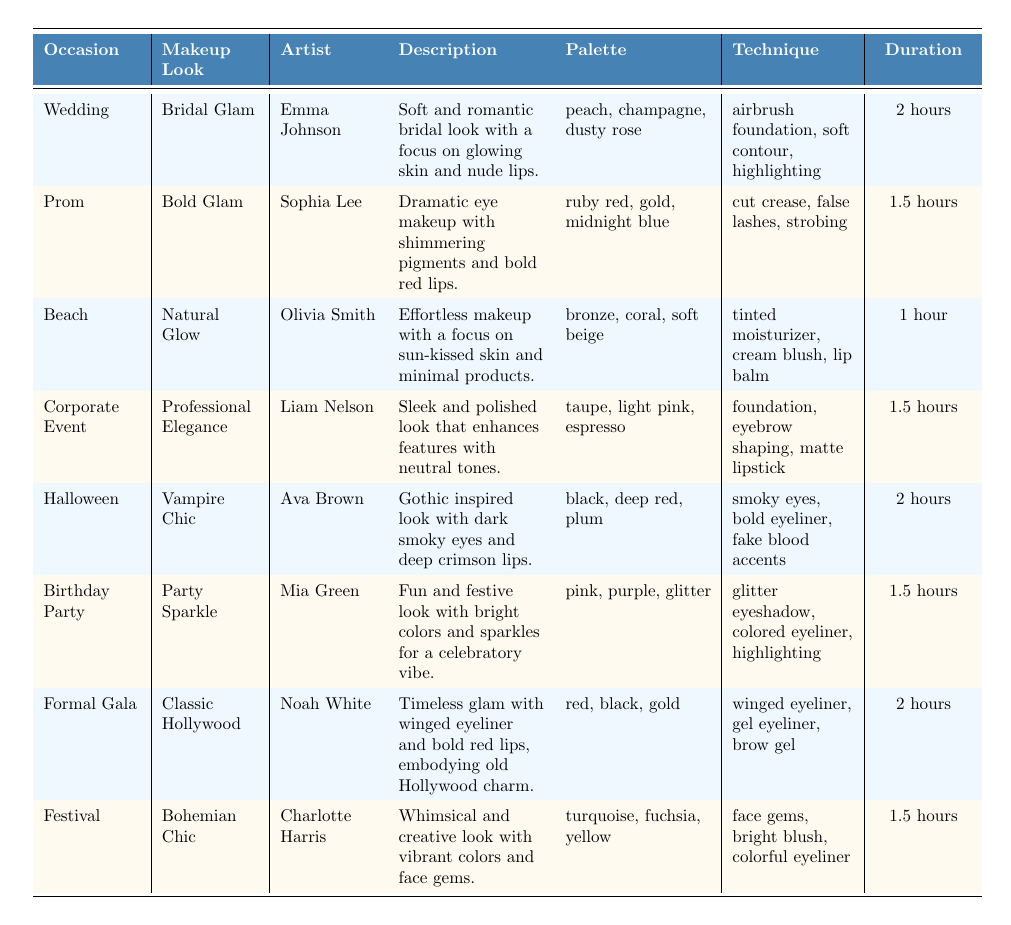What makeup look is associated with the Halloween occasion? The table indicates that the makeup look for Halloween is "Vampire Chic," as listed under the "occasion" column.
Answer: Vampire Chic Who is the artist for the makeup look "Bridal Glam"? According to the table, "Bridal Glam" was created by the artist Emma Johnson, as noted in the corresponding row.
Answer: Emma Johnson What is the duration needed for the "Party Sparkle" makeup look? From the table, the duration for the "Party Sparkle" makeup look is 1.5 hours, as specified in the duration column for that row.
Answer: 1.5 hours Is the "Natural Glow" makeup look designed for a birthday party? The table shows that "Natural Glow" is specifically associated with the Beach occasion, not a birthday party, as reflected in the occasions listed.
Answer: No Which makeup look requires the most time to complete? By analyzing the durations listed, "Bridal Glam," "Vampire Chic," and "Classic Hollywood" all require 2 hours, which is the maximum duration mentioned in the table.
Answer: Bridal Glam, Vampire Chic, Classic Hollywood What palette is used for the "Bohemian Chic" makeup look? The table lists "Bohemian Chic" under festival, and its palette includes turquoise, fuchsia, and yellow, as indicated in the corresponding row.
Answer: Turquoise, fuchsia, yellow What is the average duration of makeup looks listed for events with a duration of 1.5 hours? There are three makeup looks (Bold Glam, Professional Elegance, Party Sparkle) with a duration of 1.5 hours, totaling (1.5 + 1.5 + 1.5) = 4.5 hours. Dividing this by the number of looks (3), the average duration is 4.5/3 = 1.5 hours.
Answer: 1.5 hours Which occasion has the description mentioning "gothic inspired look with dark smoky eyes"? The description for the "Vampire Chic" makeup look mentions this gothic theme, which is categorized under the Halloween occasion in the table.
Answer: Halloween If a makeup artist specializes in techniques like "winged eyeliner" and "gel eyeliner," which makeup look might they be most suited for? The table shows that these techniques are used in the "Classic Hollywood" makeup look. Therefore, an artist skilled in these techniques would likely be suited for that look.
Answer: Classic Hollywood Which makeup look uses the largest variety of colors in its palette? The "Party Sparkle" makeup look is the only one that has 3 different colors and includes glitter, making it stand out with its vibrant palette among the listed looks.
Answer: Party Sparkle 